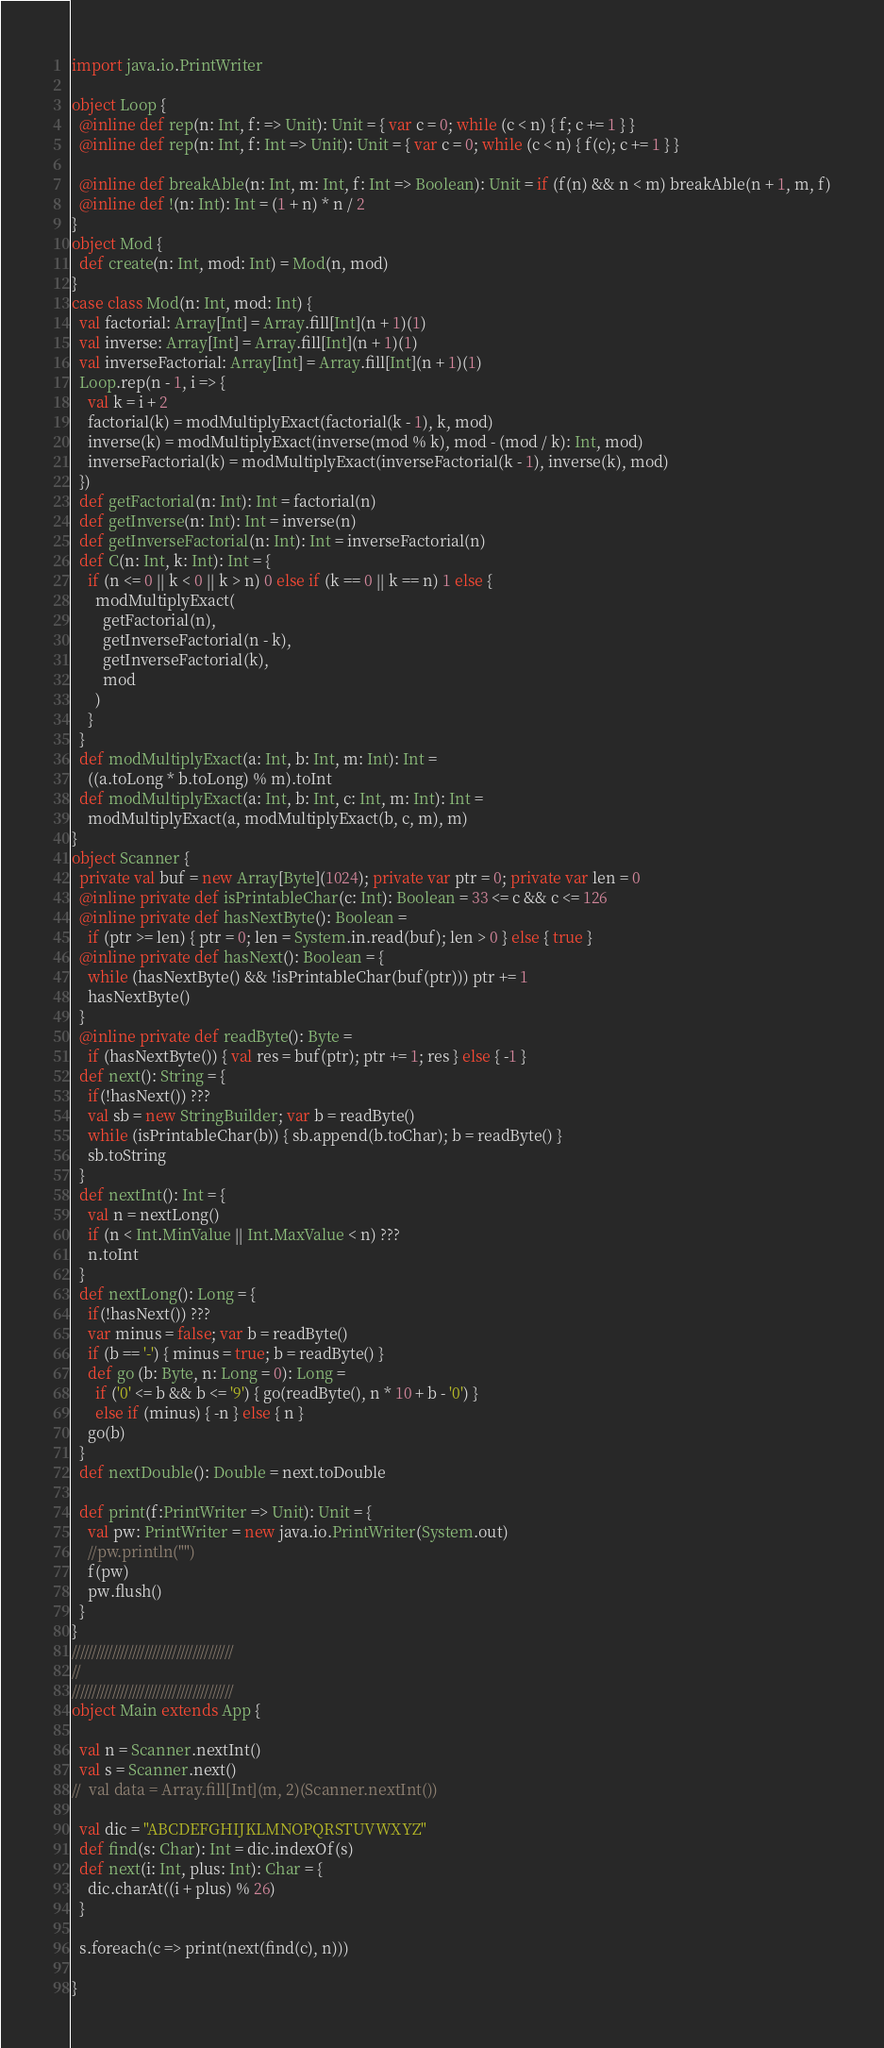Convert code to text. <code><loc_0><loc_0><loc_500><loc_500><_Scala_>import java.io.PrintWriter

object Loop {
  @inline def rep(n: Int, f: => Unit): Unit = { var c = 0; while (c < n) { f; c += 1 } }
  @inline def rep(n: Int, f: Int => Unit): Unit = { var c = 0; while (c < n) { f(c); c += 1 } }

  @inline def breakAble(n: Int, m: Int, f: Int => Boolean): Unit = if (f(n) && n < m) breakAble(n + 1, m, f)
  @inline def !(n: Int): Int = (1 + n) * n / 2
}
object Mod {
  def create(n: Int, mod: Int) = Mod(n, mod)
}
case class Mod(n: Int, mod: Int) {
  val factorial: Array[Int] = Array.fill[Int](n + 1)(1)
  val inverse: Array[Int] = Array.fill[Int](n + 1)(1)
  val inverseFactorial: Array[Int] = Array.fill[Int](n + 1)(1)
  Loop.rep(n - 1, i => {
    val k = i + 2
    factorial(k) = modMultiplyExact(factorial(k - 1), k, mod)
    inverse(k) = modMultiplyExact(inverse(mod % k), mod - (mod / k): Int, mod)
    inverseFactorial(k) = modMultiplyExact(inverseFactorial(k - 1), inverse(k), mod)
  })
  def getFactorial(n: Int): Int = factorial(n)
  def getInverse(n: Int): Int = inverse(n)
  def getInverseFactorial(n: Int): Int = inverseFactorial(n)
  def C(n: Int, k: Int): Int = {
    if (n <= 0 || k < 0 || k > n) 0 else if (k == 0 || k == n) 1 else {
      modMultiplyExact(
        getFactorial(n),
        getInverseFactorial(n - k),
        getInverseFactorial(k),
        mod
      )
    }
  }
  def modMultiplyExact(a: Int, b: Int, m: Int): Int =
    ((a.toLong * b.toLong) % m).toInt
  def modMultiplyExact(a: Int, b: Int, c: Int, m: Int): Int =
    modMultiplyExact(a, modMultiplyExact(b, c, m), m)
}
object Scanner {
  private val buf = new Array[Byte](1024); private var ptr = 0; private var len = 0
  @inline private def isPrintableChar(c: Int): Boolean = 33 <= c && c <= 126
  @inline private def hasNextByte(): Boolean =
    if (ptr >= len) { ptr = 0; len = System.in.read(buf); len > 0 } else { true }
  @inline private def hasNext(): Boolean = {
    while (hasNextByte() && !isPrintableChar(buf(ptr))) ptr += 1
    hasNextByte()
  }
  @inline private def readByte(): Byte =
    if (hasNextByte()) { val res = buf(ptr); ptr += 1; res } else { -1 }
  def next(): String = {
    if(!hasNext()) ???
    val sb = new StringBuilder; var b = readByte()
    while (isPrintableChar(b)) { sb.append(b.toChar); b = readByte() }
    sb.toString
  }
  def nextInt(): Int = {
    val n = nextLong()
    if (n < Int.MinValue || Int.MaxValue < n) ???
    n.toInt
  }
  def nextLong(): Long = {
    if(!hasNext()) ???
    var minus = false; var b = readByte()
    if (b == '-') { minus = true; b = readByte() }
    def go (b: Byte, n: Long = 0): Long =
      if ('0' <= b && b <= '9') { go(readByte(), n * 10 + b - '0') }
      else if (minus) { -n } else { n }
    go(b)
  }
  def nextDouble(): Double = next.toDouble

  def print(f:PrintWriter => Unit): Unit = {
    val pw: PrintWriter = new java.io.PrintWriter(System.out)
    //pw.println("")
    f(pw)
    pw.flush()
  }
}
////////////////////////////////////////
//
////////////////////////////////////////
object Main extends App {

  val n = Scanner.nextInt()
  val s = Scanner.next()
//  val data = Array.fill[Int](m, 2)(Scanner.nextInt())

  val dic = "ABCDEFGHIJKLMNOPQRSTUVWXYZ"
  def find(s: Char): Int = dic.indexOf(s)
  def next(i: Int, plus: Int): Char = {
    dic.charAt((i + plus) % 26)
  }

  s.foreach(c => print(next(find(c), n)))

}</code> 